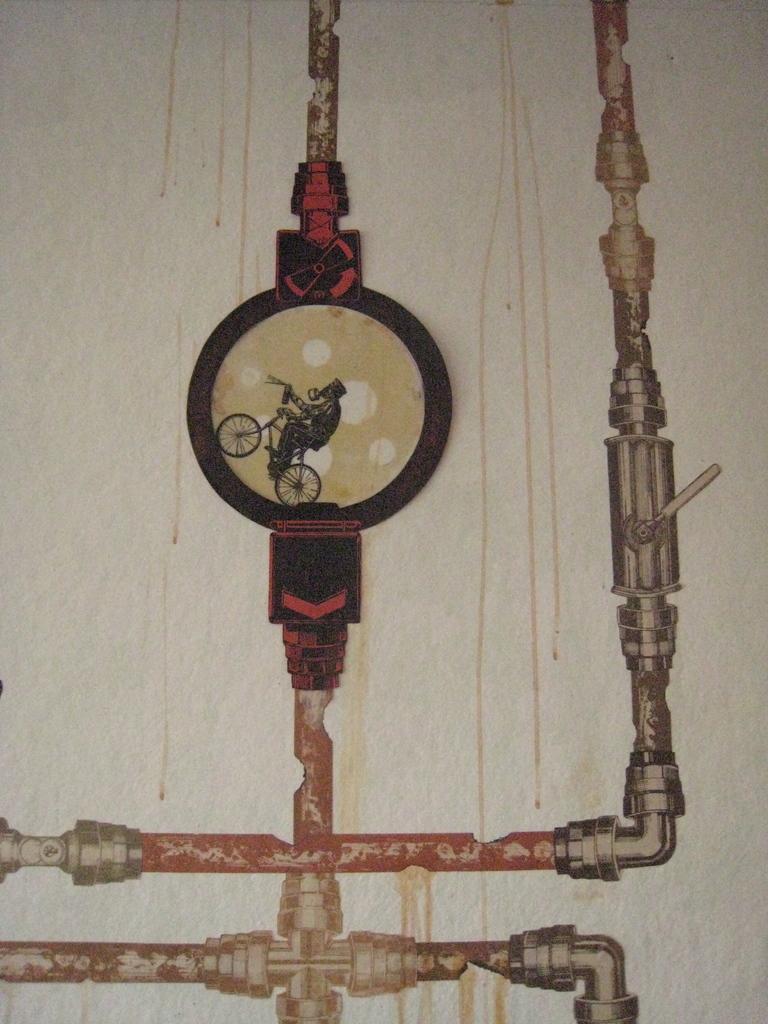In one or two sentences, can you explain what this image depicts? In this image I can see it looks like a painting, in the middle a man is riding the cycle. 